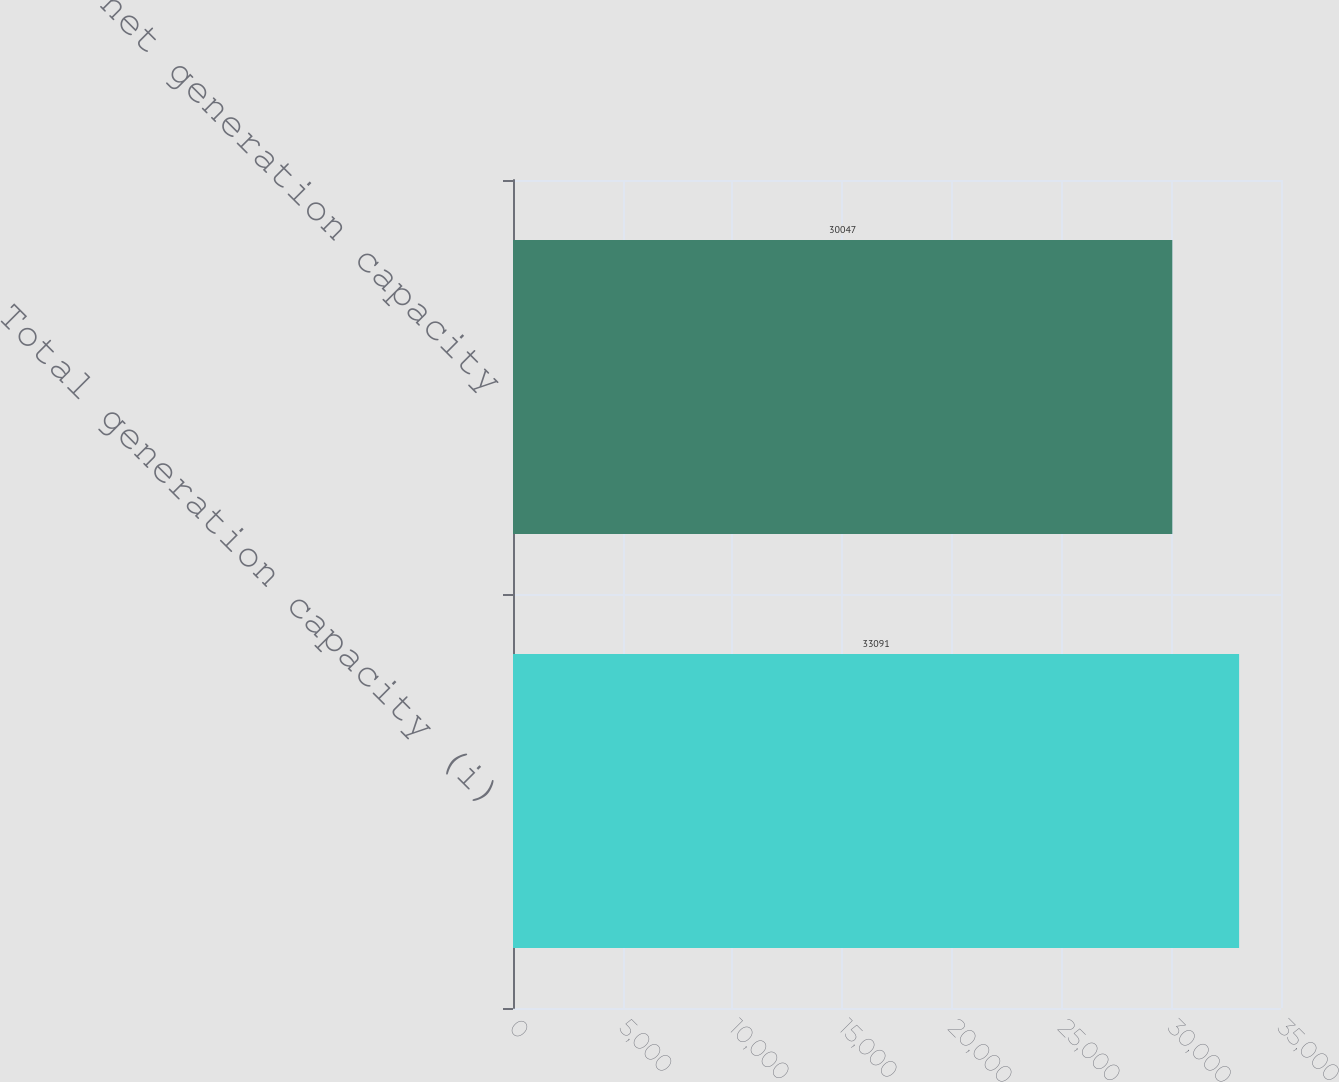Convert chart to OTSL. <chart><loc_0><loc_0><loc_500><loc_500><bar_chart><fcel>Total generation capacity (i)<fcel>Total net generation capacity<nl><fcel>33091<fcel>30047<nl></chart> 